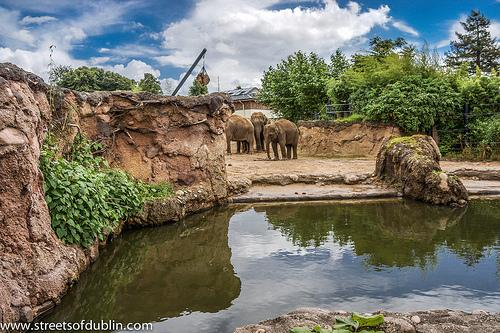Explain the interaction between the water and its surroundings in the image. The water interacts with the surroundings by reflecting elements on its surface, touching the edge of the cliff, and being near the herd of elephants. Identify the primary action occurring in the image involving the elephants. A herd of brown elephants is standing on the dirt near the water. Is there any man-made object present in the image? If yes, describe it briefly. Yes, there is a pole with a brown bag attached to it in the image. Based on the image's information, determine the emotional tone or sentiment associated with the scene. The image portrays a sense of calmness and serenity with the presence of a large pool of water, the blue sky, and the elephants near the water. Which animal species is predominantly featured in the image? A herd of elephants is the main animal species in the image. Discuss the presence and role of vegetation in the image. The vegetation in the image includes green vine on the cliff, dense foliage behind the fence, and a green bush vine, providing a natural environment and contrasting color scheme. Mention the key elements associated with the surrounding environment in the picture. Bright blue sky with clouds, brown cliff side, large pool of water, and dense foliage behind the fence are present. How would you describe the overall color palette of the image? The image has a mix of brown, green, and blue, with brown dominating the scene. Analyze the significance of the large pool of water in relation to the entire image. The large pool of water occupies a vast portion of the image, reflecting the environment and attracting the elephants, thus being a focal point and a significant component of the scene. Count the number of distinct water captions from the image description list. There are 13 instances mentioning the water in different locations and states. Is there a fence made of stone in the image? The fence is not mentioned in the image, only dense foliage behind a fence. This instruction would make someone look for a stone fence, which is not present in the image. Can you find a small pool of water surrounded by grass? The image mentions a large pool of water, but not a small one, and there's no reference to grass. This instruction would make someone search for a small pool of water surrounded by grass that is not described in the image. Can you find a bird sitting on the pole with a brown bag? A pole with a brown bag is mentioned in the image, but no reference to any bird sitting on it. This instruction would make someone search for a bird that doesn't exist in the image. Can you see a tree with red leaves in the image? A large tree in the distance is mentioned, but there is no reference to the leaves being red. This instruction would lead someone to try to find a tree with red leaves, which is not mentioned in the image. Is the sky purple and cloudy in the image? The image mentions a blue cloudy sky but not a purple one. This instruction would make someone look for a purple sky, which is not present in the image. Is there a pink elephant in the image? There are brown elephants mentioned in the image, but no reference to any pink elephants. This instruction would make someone look for an object that doesn't exist. 